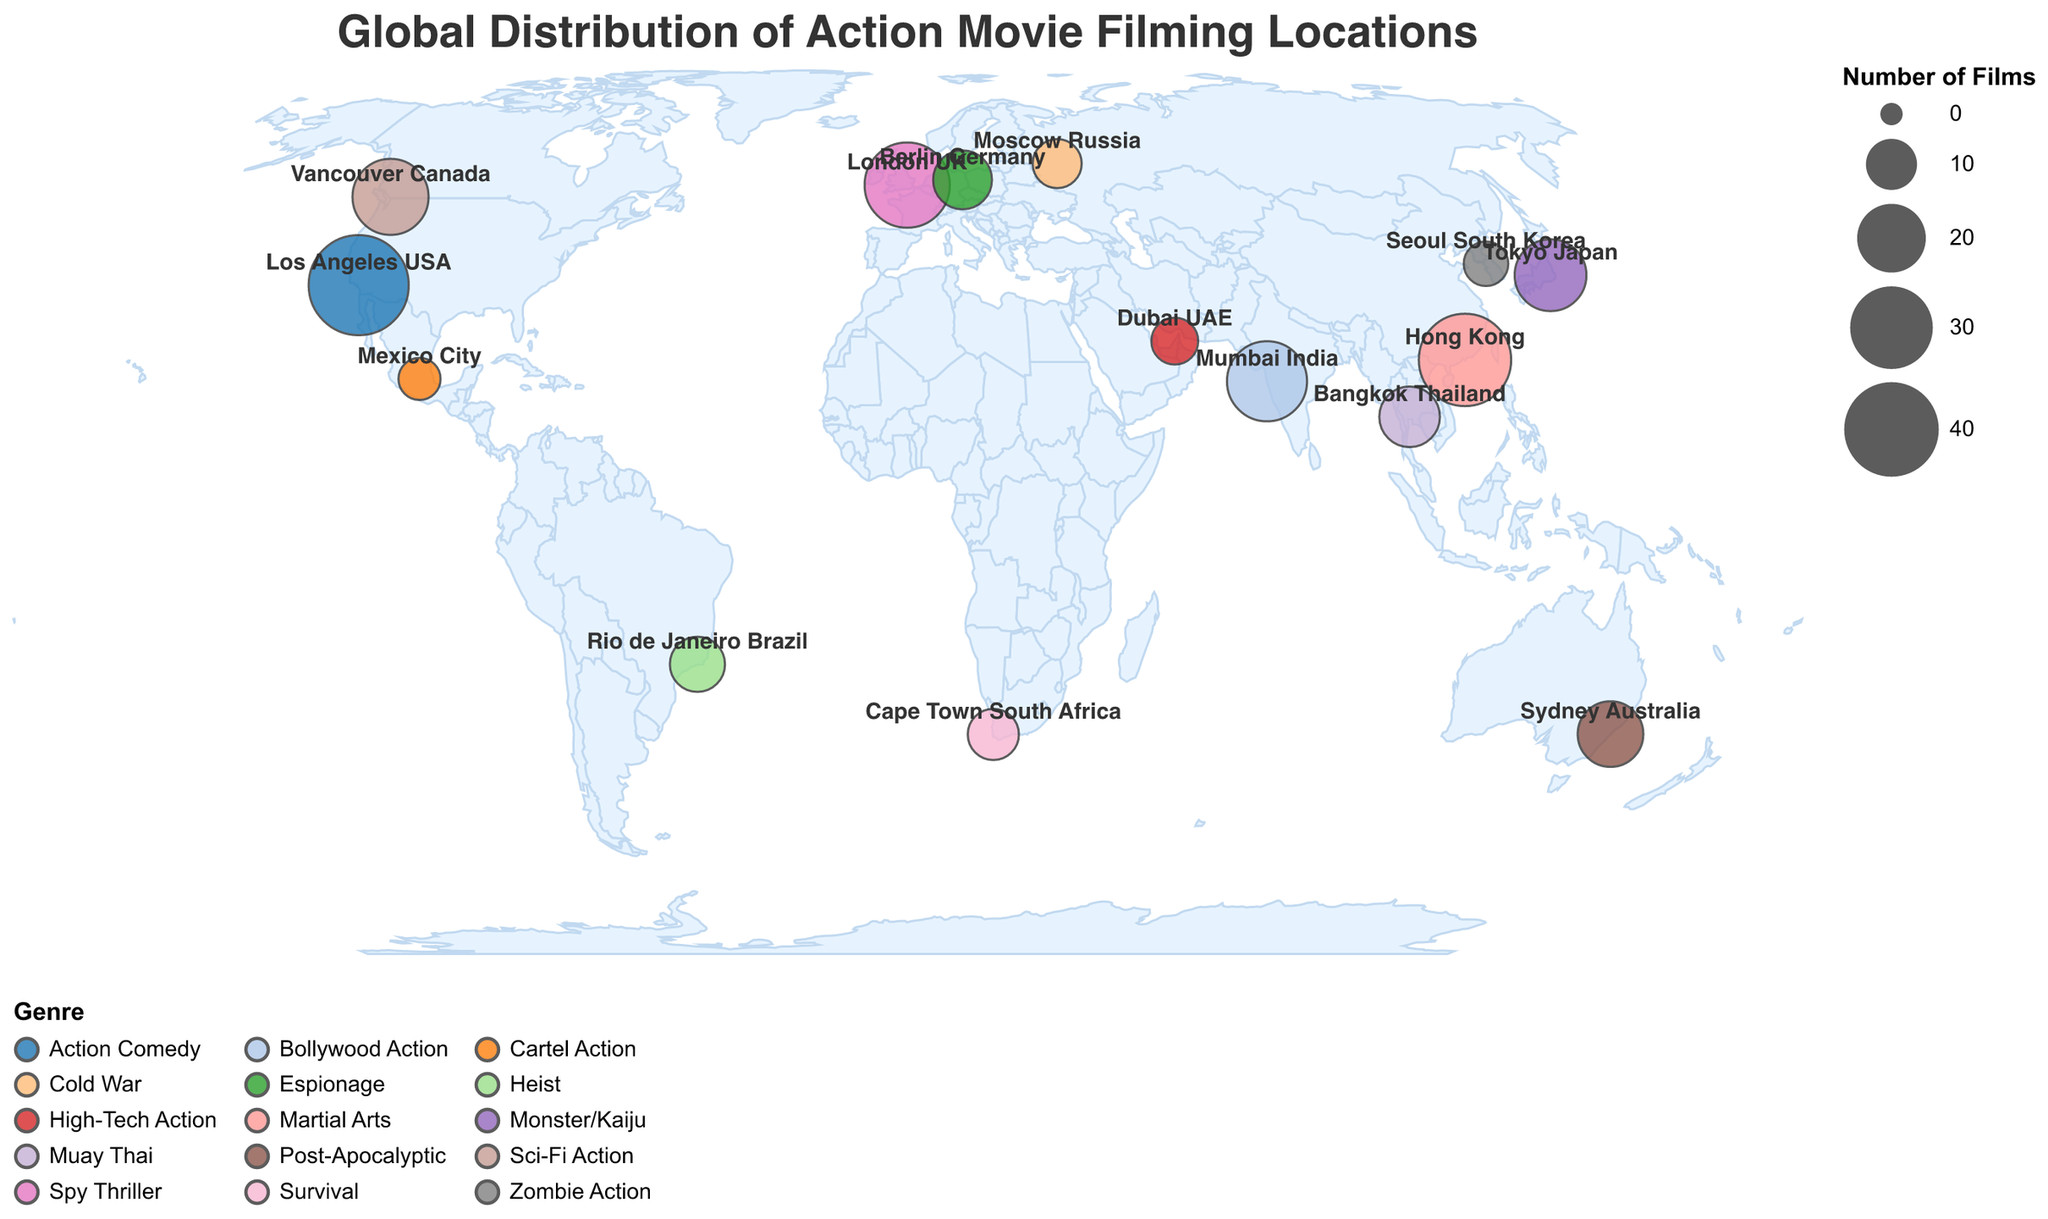Which location has the highest number of action films? To determine the location with the highest number of action films, look for the location with the largest circle (indicating the highest number of films) on the plot. "Los Angeles USA" has the largest circle, representing 45 films.
Answer: Los Angeles USA Which genre is most popular in Tokyo Japan? Each location's genre is color-coded and labeled. The genre associated with Tokyo Japan can be found in the tooltip or by matching the color. Tokyo Japan is labeled with "Monster/Kaiju".
Answer: Monster/Kaiju Compare the number of action films made in Vancouver Canada to those made in Mumbai India. Which location has more films, and by how many? Identify the number of films in Vancouver Canada (25) and Mumbai India (28) from the circles on the plot or the tooltips. Mumbai India has 28 films, while Vancouver Canada has 25 films. The difference is 28 - 25 = 3 films.
Answer: Mumbai India, by 3 films What is the total number of films across all listed locations? Sum the number of films for each location: 45 (Los Angeles USA) + 38 (Hong Kong) + 32 (London UK) + 28 (Mumbai India) + 25 (Vancouver Canada) + 22 (Tokyo Japan) + 18 (Sydney Australia) + 15 (Bangkok Thailand) + 14 (Berlin Germany) + 12 (Rio de Janeiro Brazil) + 10 (Cape Town South Africa) + 9 (Moscow Russia) + 8 (Dubai UAE) + 7 (Seoul South Korea) + 6 (Mexico City) = 289 films.
Answer: 289 films Which genre has the least number of films, and where is it filmed? Look for the smallest circles on the plot and their corresponding genres and locations. The smallest circles represent "Cartel Action" in Mexico City with 6 films.
Answer: Cartel Action, Mexico City How many more films are made in London UK compared to Berlin Germany? Determine the number of films in London UK (32) and Berlin Germany (14) from the circles on the plot or the tooltips. The difference is 32 - 14 = 18 films.
Answer: 18 films Which notable actor is associated with the Cold War genre? Check the tooltip or labels in the plot for the "Cold War" genre associated with Moscow Russia. The notable actor listed is "Milla Jovovich".
Answer: Milla Jovovich What is the average number of films across all locations? Sum the total number of films from each location (289 films) and divide by the number of locations (15): 289 / 15 = 19.27 films.
Answer: 19.27 films Which location hosts the genre "Heist"? Look for the genre "Heist" in the tooltips or labels and find its corresponding location. "Heist" is associated with Rio de Janeiro Brazil.
Answer: Rio de Janeiro Brazil 